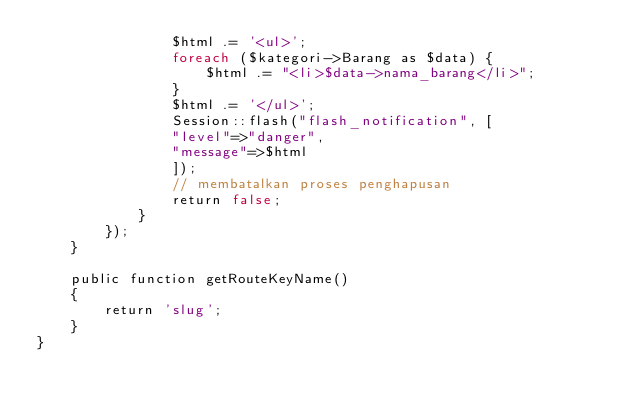<code> <loc_0><loc_0><loc_500><loc_500><_PHP_>                $html .= '<ul>';
                foreach ($kategori->Barang as $data) {
                    $html .= "<li>$data->nama_barang</li>";
                }
                $html .= '</ul>';
                Session::flash("flash_notification", [
                "level"=>"danger",
                "message"=>$html
                ]);
                // membatalkan proses penghapusan
                return false;
            }
        });
    }

    public function getRouteKeyName()
    {
        return 'slug';
    }
}
</code> 